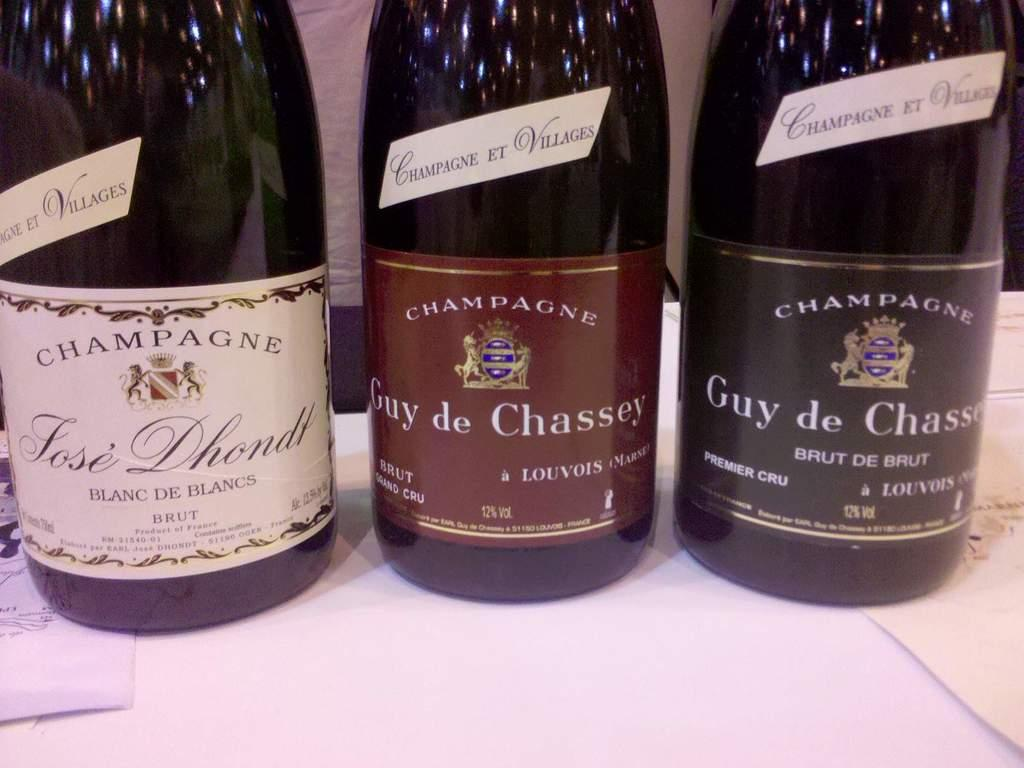<image>
Present a compact description of the photo's key features. Three bottles of champagne are lined up together and brut can be seen on the labels. 